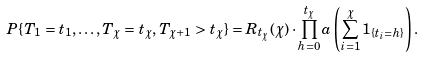Convert formula to latex. <formula><loc_0><loc_0><loc_500><loc_500>P \{ T _ { 1 } = t _ { 1 } , \dots , T _ { \chi } = t _ { \chi } , T _ { \chi + 1 } > t _ { \chi } \} = R _ { t _ { \chi } } ( \chi ) \cdot \prod _ { h = 0 } ^ { t _ { \chi } } a \left ( \sum _ { i = 1 } ^ { \chi } 1 _ { \{ t _ { i } = h \} } \right ) .</formula> 